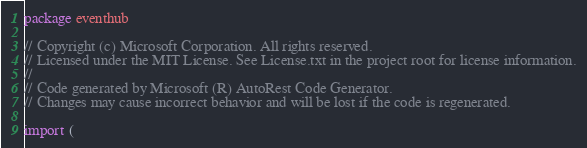<code> <loc_0><loc_0><loc_500><loc_500><_Go_>package eventhub

// Copyright (c) Microsoft Corporation. All rights reserved.
// Licensed under the MIT License. See License.txt in the project root for license information.
//
// Code generated by Microsoft (R) AutoRest Code Generator.
// Changes may cause incorrect behavior and will be lost if the code is regenerated.

import (</code> 